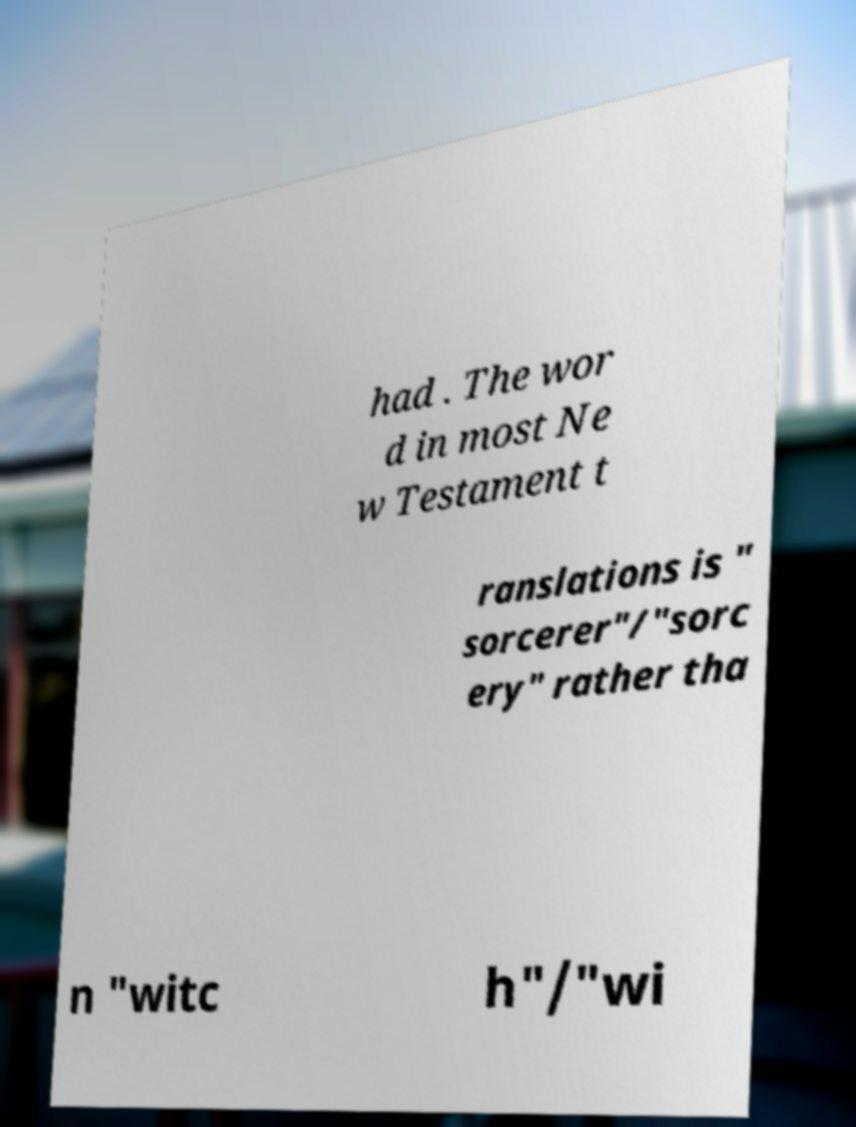Could you assist in decoding the text presented in this image and type it out clearly? had . The wor d in most Ne w Testament t ranslations is " sorcerer"/"sorc ery" rather tha n "witc h"/"wi 